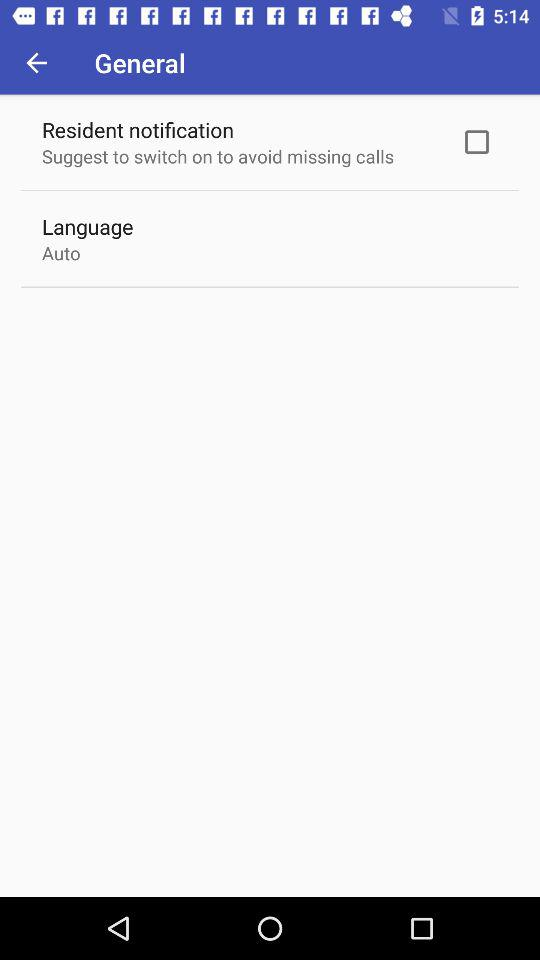What is the status of resident notification? The status is off. 